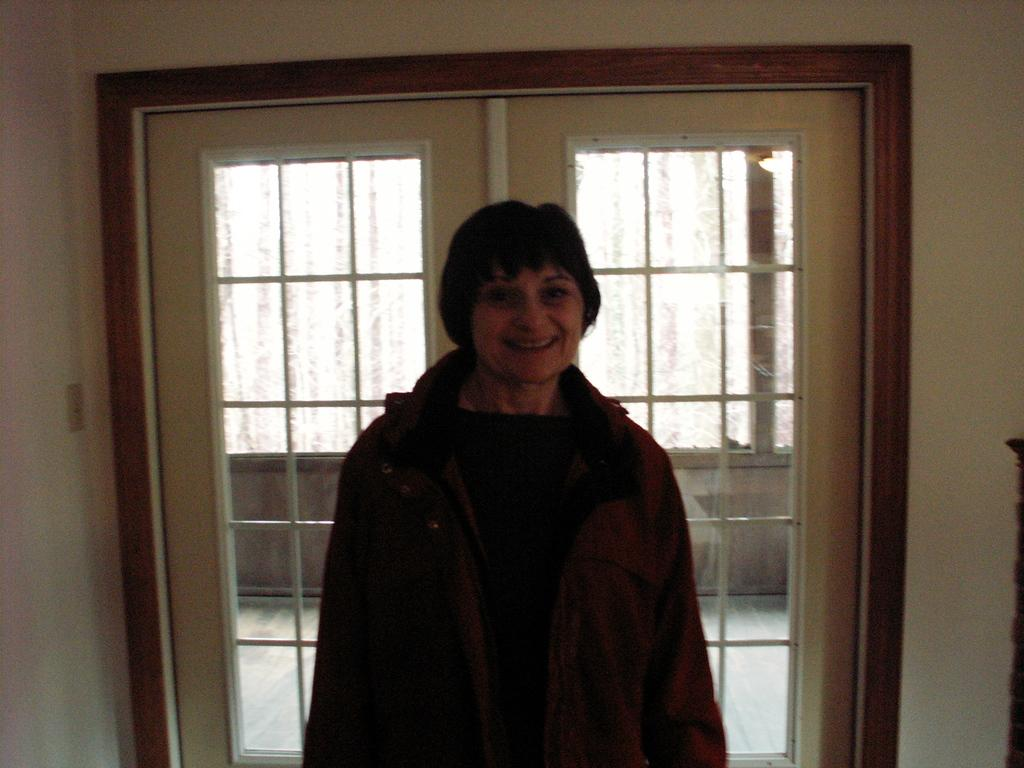Who is the main subject in the image? There is a woman in the middle of the image. What can be seen in the background of the image? There are glass windows visible in the background of the image. What is the government's rate of approval in the image? There is no information about the government's rate of approval in the image, as it only features a woman and glass windows in the background. 